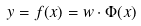<formula> <loc_0><loc_0><loc_500><loc_500>y = f ( { x } ) = w \cdot \Phi ( { x } )</formula> 